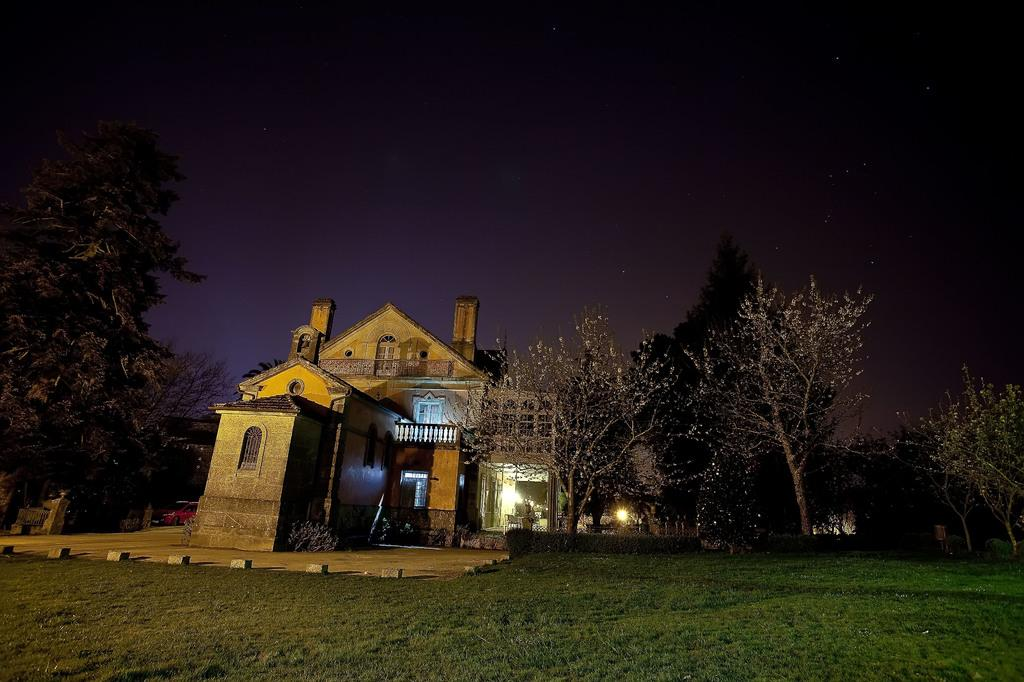What type of structure is located on the left side of the image? There is a home on the left side of the image. What can be seen around the home in the image? There are trees around the home. What type of terrain is the home situated on? The home is situated on a grassland. What time of day is depicted in the image? The image was taken at night time. What is the home's mouth doing in the image? Homes do not have mouths, so this question is not applicable to the image. 